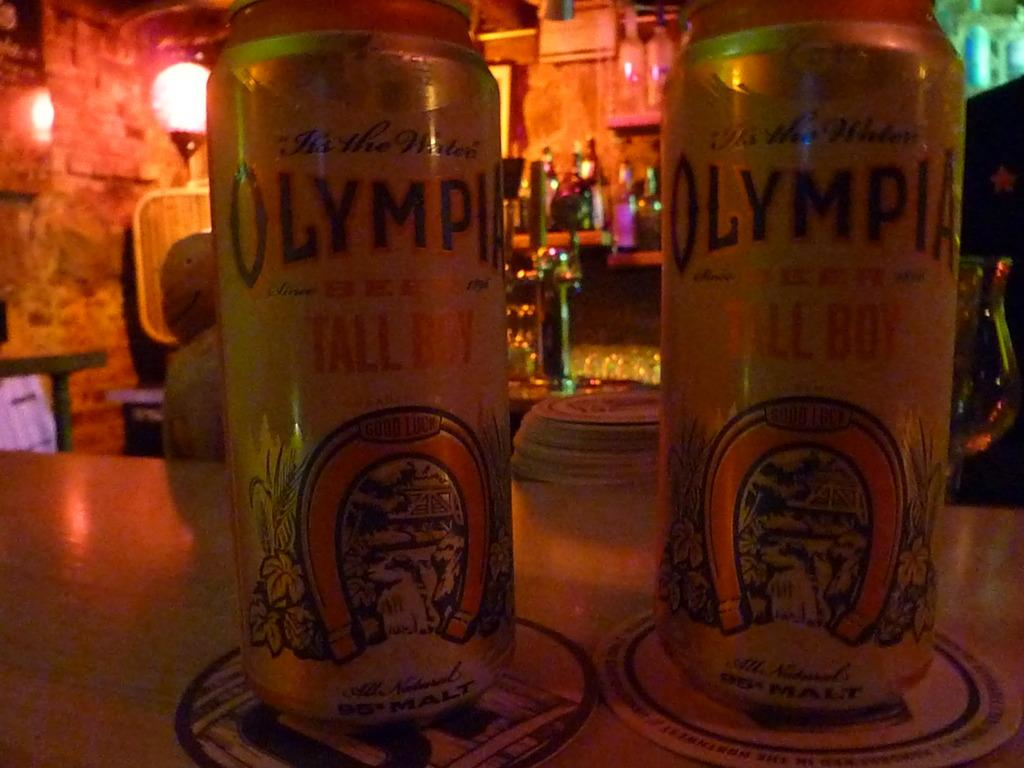Provide a one-sentence caption for the provided image. Two bottles of Olympia beer placed next to one another. 